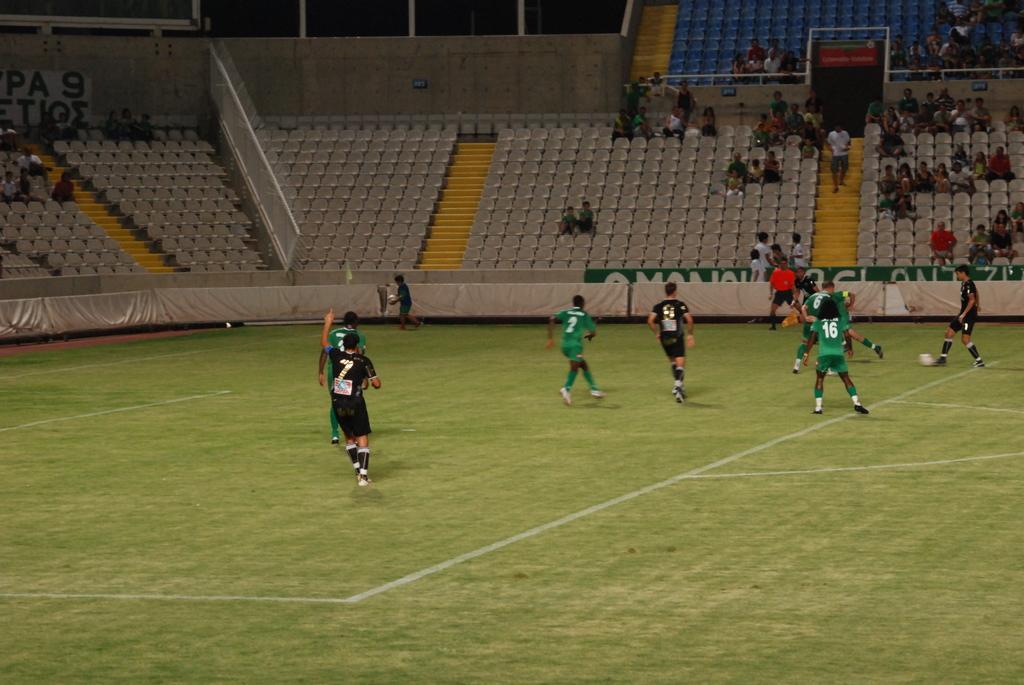Please provide a concise description of this image. There are few people running and playing football. There are group of people sitting and watching the game. I can see empty chairs in the stadium. This is a wall. This looks like a pillars. This is a football ground. 